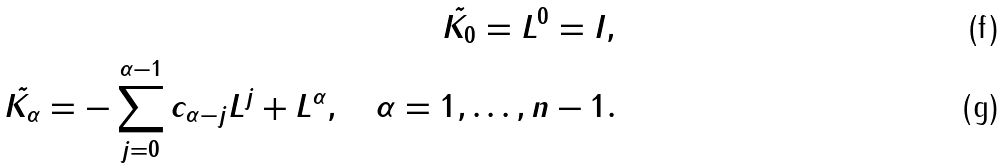Convert formula to latex. <formula><loc_0><loc_0><loc_500><loc_500>\tilde { K _ { 0 } } = L ^ { 0 } = I , \\ \tilde { K _ { \alpha } } = - \sum _ { j = 0 } ^ { \alpha - 1 } c _ { \alpha - j } L ^ { j } + L ^ { \alpha } , \quad \alpha = 1 , \dots , n - 1 .</formula> 